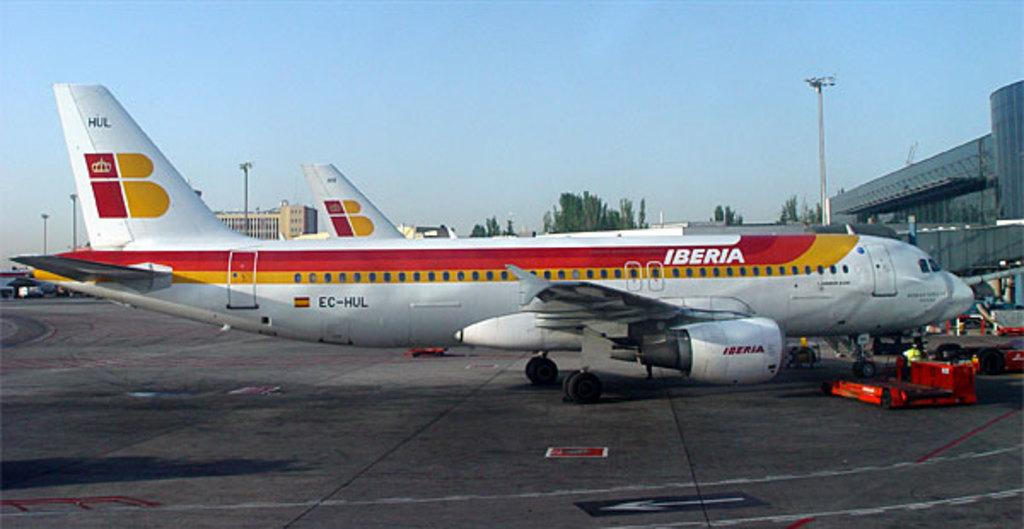<image>
Create a compact narrative representing the image presented. Two Iberia airplane sitting at their gates at an airport 